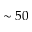Convert formula to latex. <formula><loc_0><loc_0><loc_500><loc_500>\sim 5 0</formula> 